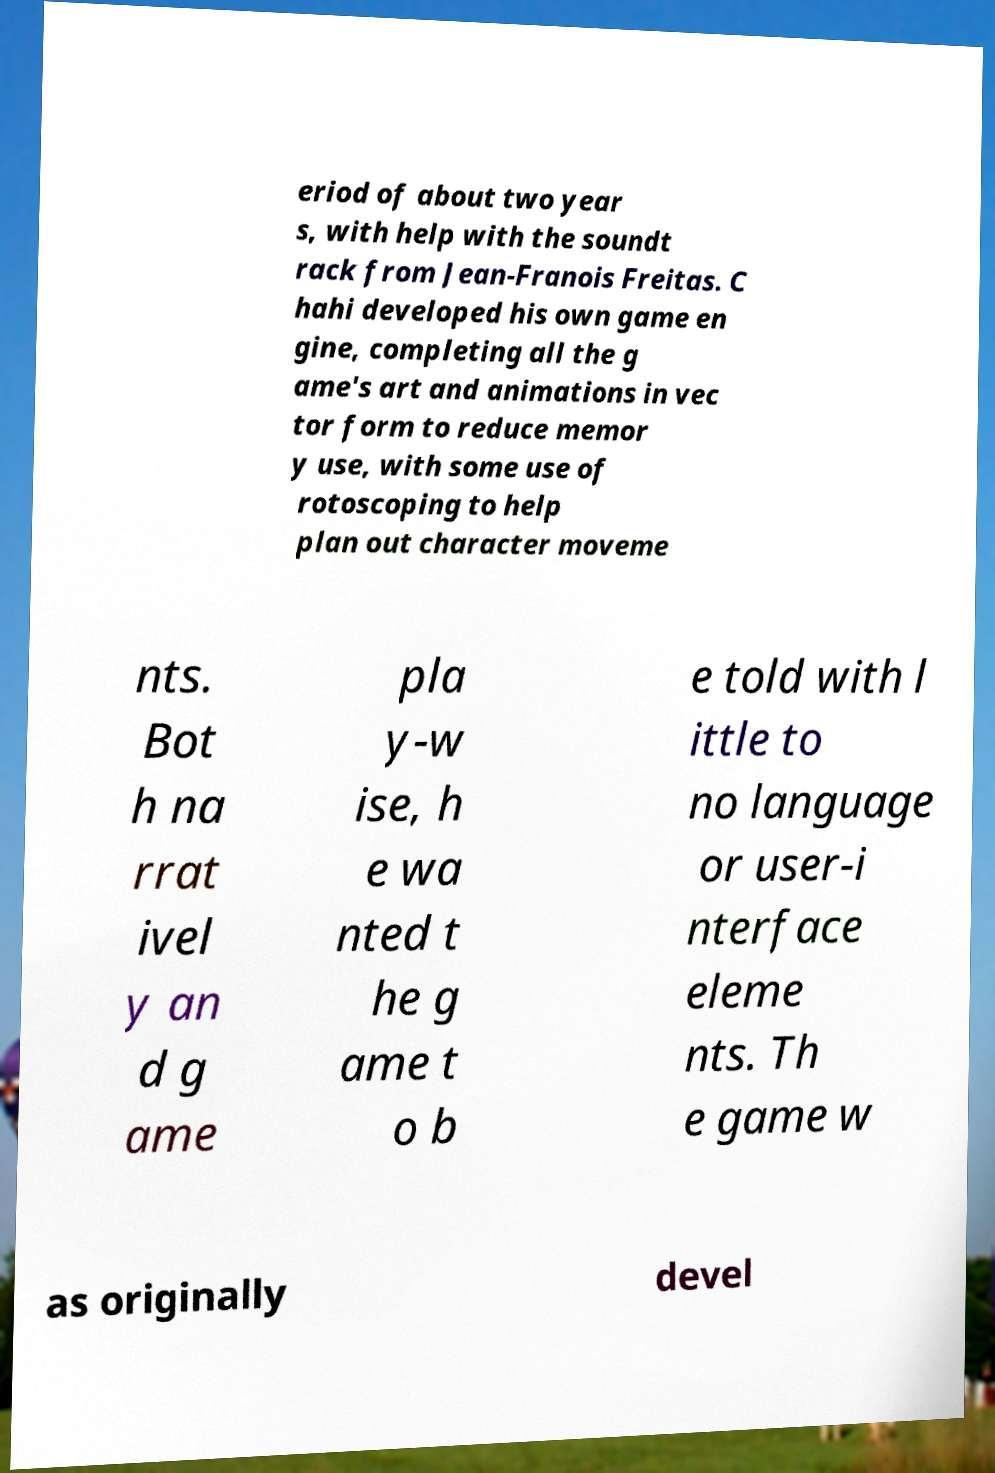I need the written content from this picture converted into text. Can you do that? eriod of about two year s, with help with the soundt rack from Jean-Franois Freitas. C hahi developed his own game en gine, completing all the g ame's art and animations in vec tor form to reduce memor y use, with some use of rotoscoping to help plan out character moveme nts. Bot h na rrat ivel y an d g ame pla y-w ise, h e wa nted t he g ame t o b e told with l ittle to no language or user-i nterface eleme nts. Th e game w as originally devel 